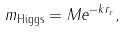Convert formula to latex. <formula><loc_0><loc_0><loc_500><loc_500>m _ { \text {Higgs} } = M e ^ { - k r _ { c } } ,</formula> 